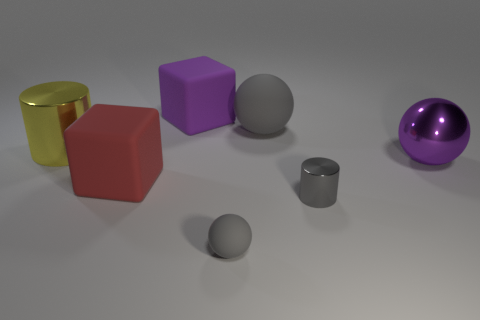Does the small metal cylinder have the same color as the tiny sphere?
Offer a very short reply. Yes. What number of matte things are either cylinders or big gray balls?
Ensure brevity in your answer.  1. There is a metal cylinder that is in front of the big rubber block that is on the left side of the large purple rubber thing; is there a large gray matte thing in front of it?
Make the answer very short. No. There is another cube that is the same material as the red block; what size is it?
Provide a succinct answer. Large. Are there any gray rubber objects in front of the large purple rubber cube?
Ensure brevity in your answer.  Yes. There is a gray rubber thing behind the big yellow metallic object; is there a big gray rubber sphere in front of it?
Offer a terse response. No. There is a gray rubber object that is behind the big yellow metallic thing; is it the same size as the metallic cylinder that is left of the tiny rubber ball?
Your response must be concise. Yes. How many small things are either purple shiny balls or gray rubber spheres?
Ensure brevity in your answer.  1. The sphere that is in front of the cube in front of the purple rubber block is made of what material?
Make the answer very short. Rubber. There is a small rubber thing that is the same color as the tiny cylinder; what shape is it?
Ensure brevity in your answer.  Sphere. 